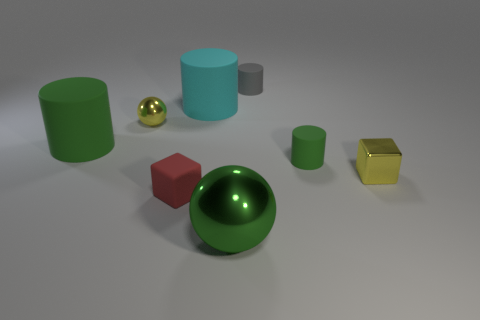Subtract all tiny gray cylinders. How many cylinders are left? 3 Subtract all green cylinders. How many cylinders are left? 2 Subtract all balls. How many objects are left? 6 Add 1 large brown matte cylinders. How many objects exist? 9 Subtract 2 spheres. How many spheres are left? 0 Subtract all gray balls. How many red cubes are left? 1 Subtract all large cyan rubber cylinders. Subtract all green things. How many objects are left? 4 Add 4 tiny green cylinders. How many tiny green cylinders are left? 5 Add 7 tiny gray cylinders. How many tiny gray cylinders exist? 8 Subtract 1 green spheres. How many objects are left? 7 